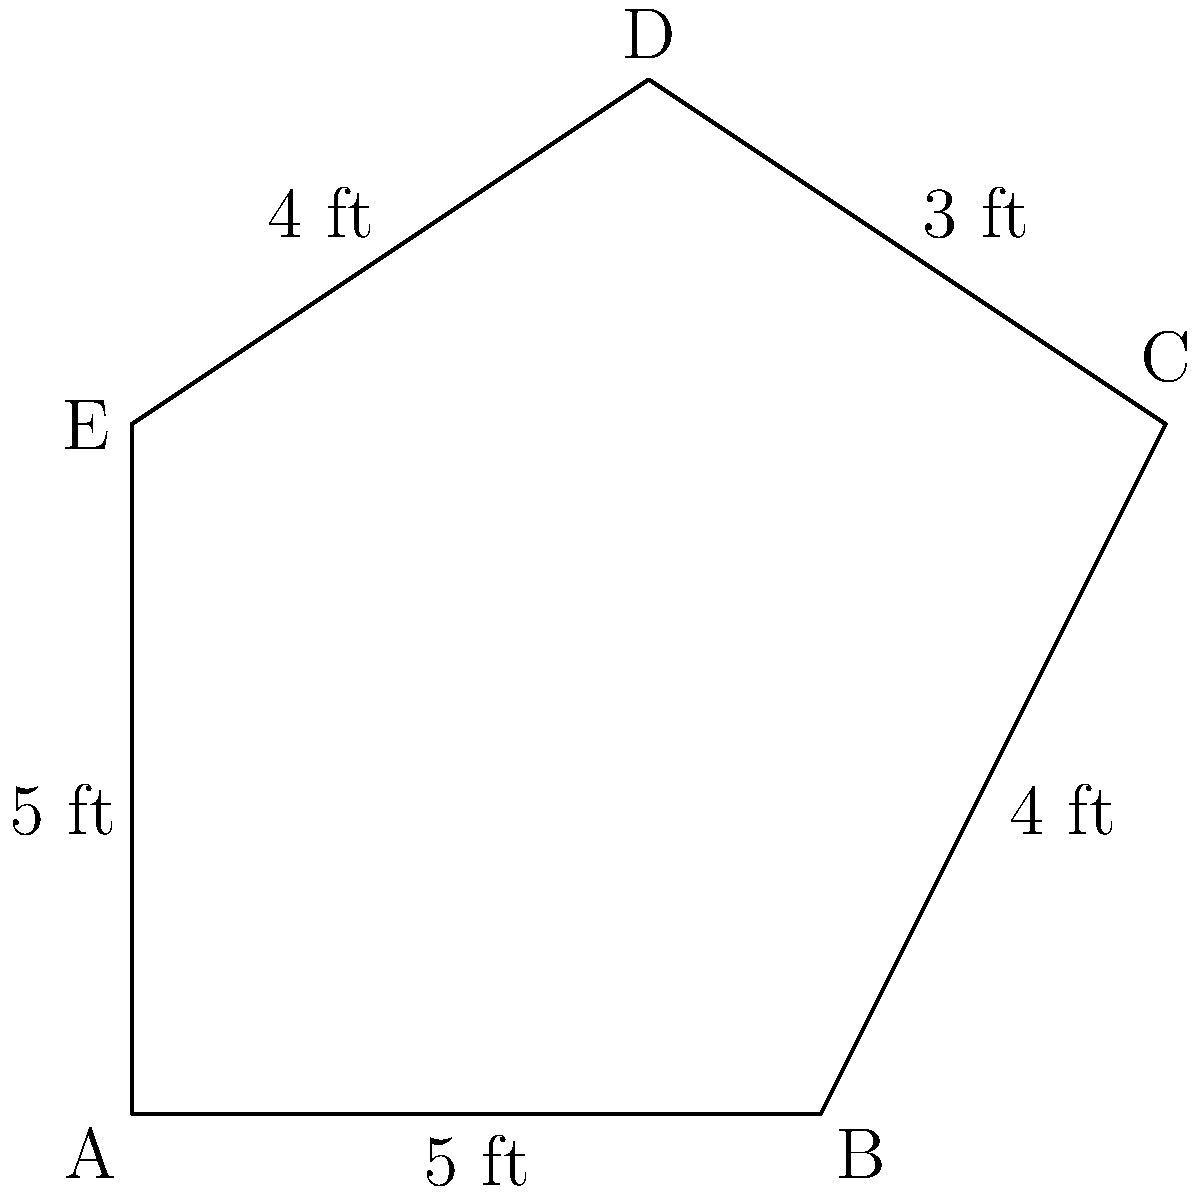The town of Belmont is planning to build a new pentagon-shaped gazebo for social events in the central park. The sides of the gazebo measure 5 ft, 4 ft, 3 ft, 4 ft, and 5 ft in order. What is the perimeter of the gazebo? To calculate the perimeter of the pentagon-shaped gazebo, we need to add up the lengths of all sides. Let's do this step by step:

1. Identify the lengths of each side:
   - Side 1: 5 ft
   - Side 2: 4 ft
   - Side 3: 3 ft
   - Side 4: 4 ft
   - Side 5: 5 ft

2. Add up all the side lengths:
   $$\text{Perimeter} = 5 \text{ ft} + 4 \text{ ft} + 3 \text{ ft} + 4 \text{ ft} + 5 \text{ ft}$$

3. Perform the addition:
   $$\text{Perimeter} = 21 \text{ ft}$$

Therefore, the perimeter of the pentagon-shaped gazebo is 21 feet.
Answer: 21 ft 